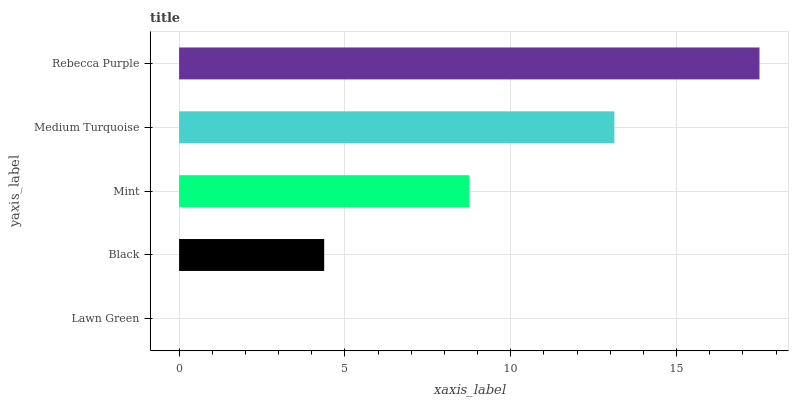Is Lawn Green the minimum?
Answer yes or no. Yes. Is Rebecca Purple the maximum?
Answer yes or no. Yes. Is Black the minimum?
Answer yes or no. No. Is Black the maximum?
Answer yes or no. No. Is Black greater than Lawn Green?
Answer yes or no. Yes. Is Lawn Green less than Black?
Answer yes or no. Yes. Is Lawn Green greater than Black?
Answer yes or no. No. Is Black less than Lawn Green?
Answer yes or no. No. Is Mint the high median?
Answer yes or no. Yes. Is Mint the low median?
Answer yes or no. Yes. Is Black the high median?
Answer yes or no. No. Is Black the low median?
Answer yes or no. No. 